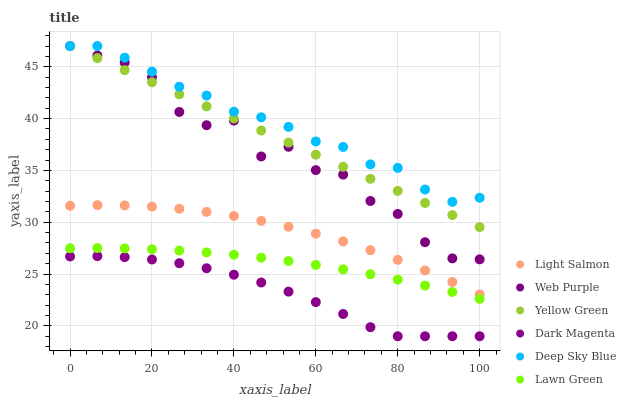Does Dark Magenta have the minimum area under the curve?
Answer yes or no. Yes. Does Deep Sky Blue have the maximum area under the curve?
Answer yes or no. Yes. Does Light Salmon have the minimum area under the curve?
Answer yes or no. No. Does Light Salmon have the maximum area under the curve?
Answer yes or no. No. Is Yellow Green the smoothest?
Answer yes or no. Yes. Is Web Purple the roughest?
Answer yes or no. Yes. Is Light Salmon the smoothest?
Answer yes or no. No. Is Light Salmon the roughest?
Answer yes or no. No. Does Dark Magenta have the lowest value?
Answer yes or no. Yes. Does Light Salmon have the lowest value?
Answer yes or no. No. Does Yellow Green have the highest value?
Answer yes or no. Yes. Does Light Salmon have the highest value?
Answer yes or no. No. Is Light Salmon less than Yellow Green?
Answer yes or no. Yes. Is Light Salmon greater than Dark Magenta?
Answer yes or no. Yes. Does Web Purple intersect Deep Sky Blue?
Answer yes or no. Yes. Is Web Purple less than Deep Sky Blue?
Answer yes or no. No. Is Web Purple greater than Deep Sky Blue?
Answer yes or no. No. Does Light Salmon intersect Yellow Green?
Answer yes or no. No. 